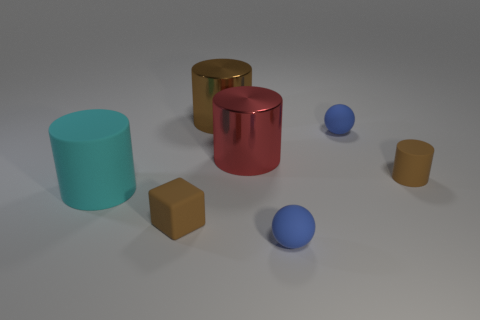There is a cyan rubber object that is the same shape as the red metal thing; what size is it?
Ensure brevity in your answer.  Large. Do the small rubber cube and the tiny matte cylinder have the same color?
Make the answer very short. Yes. The other metal object that is the same shape as the large red thing is what color?
Ensure brevity in your answer.  Brown. Is the cyan object made of the same material as the small brown cylinder?
Make the answer very short. Yes. Is the big brown object the same shape as the large red object?
Give a very brief answer. Yes. Are there an equal number of big cyan rubber cylinders to the left of the big cyan matte thing and large brown objects that are to the left of the brown rubber cylinder?
Provide a succinct answer. No. There is a big thing that is made of the same material as the small cube; what is its color?
Keep it short and to the point. Cyan. There is a matte object that is the same size as the red metallic thing; what is its color?
Offer a very short reply. Cyan. How many other objects are there of the same size as the matte cube?
Keep it short and to the point. 3. The small cylinder has what color?
Make the answer very short. Brown. 